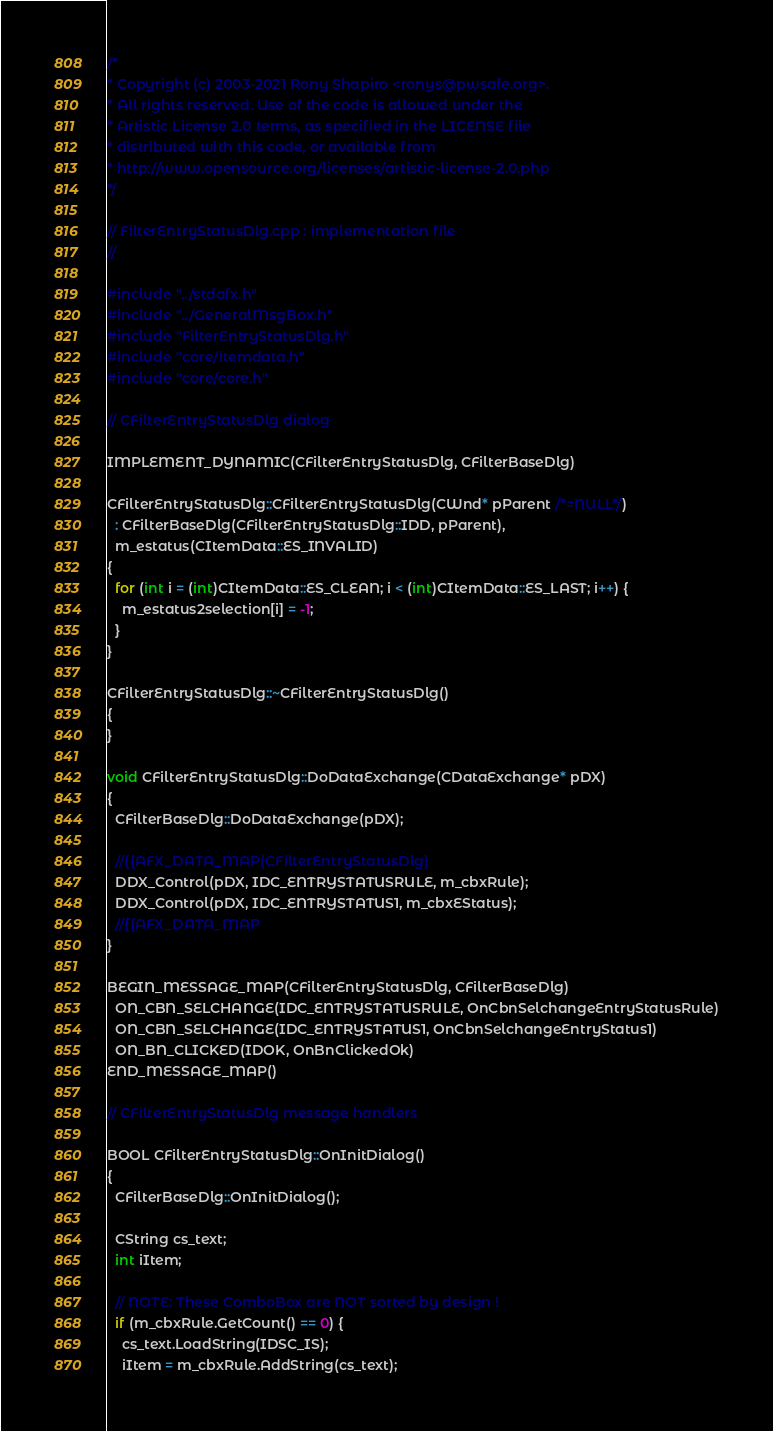Convert code to text. <code><loc_0><loc_0><loc_500><loc_500><_C++_>/*
* Copyright (c) 2003-2021 Rony Shapiro <ronys@pwsafe.org>.
* All rights reserved. Use of the code is allowed under the
* Artistic License 2.0 terms, as specified in the LICENSE file
* distributed with this code, or available from
* http://www.opensource.org/licenses/artistic-license-2.0.php
*/

// FilterEntryStatusDlg.cpp : implementation file
//

#include "../stdafx.h"
#include "../GeneralMsgBox.h"
#include "FilterEntryStatusDlg.h"
#include "core/itemdata.h"
#include "core/core.h"

// CFilterEntryStatusDlg dialog

IMPLEMENT_DYNAMIC(CFilterEntryStatusDlg, CFilterBaseDlg)

CFilterEntryStatusDlg::CFilterEntryStatusDlg(CWnd* pParent /*=NULL*/)
  : CFilterBaseDlg(CFilterEntryStatusDlg::IDD, pParent),
  m_estatus(CItemData::ES_INVALID)
{
  for (int i = (int)CItemData::ES_CLEAN; i < (int)CItemData::ES_LAST; i++) {
    m_estatus2selection[i] = -1;
  }
}

CFilterEntryStatusDlg::~CFilterEntryStatusDlg()
{
}

void CFilterEntryStatusDlg::DoDataExchange(CDataExchange* pDX)
{
  CFilterBaseDlg::DoDataExchange(pDX);

  //{{AFX_DATA_MAP(CFilterEntryStatusDlg)
  DDX_Control(pDX, IDC_ENTRYSTATUSRULE, m_cbxRule);
  DDX_Control(pDX, IDC_ENTRYSTATUS1, m_cbxEStatus);
  //{{AFX_DATA_MAP
}

BEGIN_MESSAGE_MAP(CFilterEntryStatusDlg, CFilterBaseDlg)
  ON_CBN_SELCHANGE(IDC_ENTRYSTATUSRULE, OnCbnSelchangeEntryStatusRule)
  ON_CBN_SELCHANGE(IDC_ENTRYSTATUS1, OnCbnSelchangeEntryStatus1)
  ON_BN_CLICKED(IDOK, OnBnClickedOk)
END_MESSAGE_MAP()

// CFilterEntryStatusDlg message handlers

BOOL CFilterEntryStatusDlg::OnInitDialog()
{
  CFilterBaseDlg::OnInitDialog();

  CString cs_text;
  int iItem;

  // NOTE: These ComboBox are NOT sorted by design !
  if (m_cbxRule.GetCount() == 0) {
    cs_text.LoadString(IDSC_IS);
    iItem = m_cbxRule.AddString(cs_text);</code> 